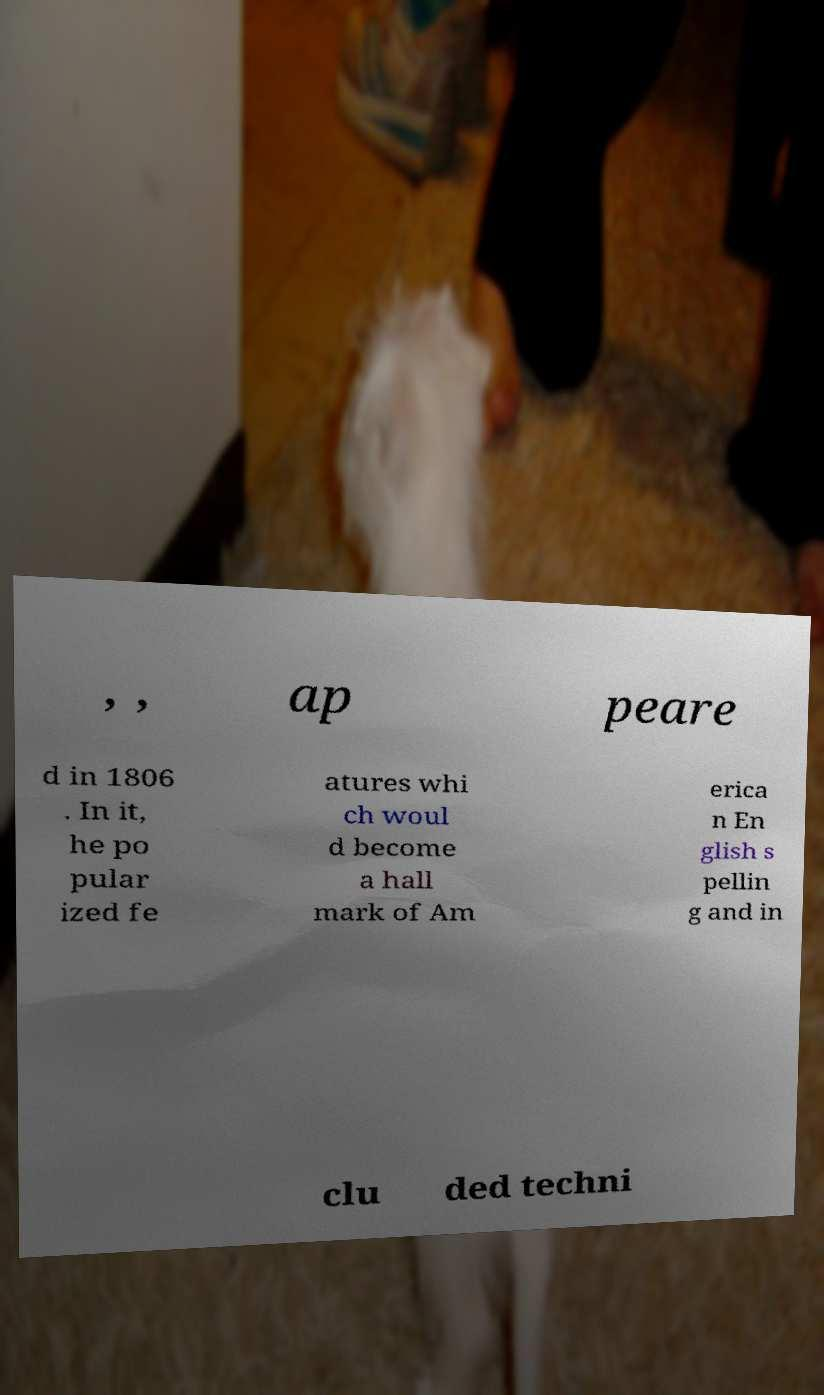I need the written content from this picture converted into text. Can you do that? , , ap peare d in 1806 . In it, he po pular ized fe atures whi ch woul d become a hall mark of Am erica n En glish s pellin g and in clu ded techni 